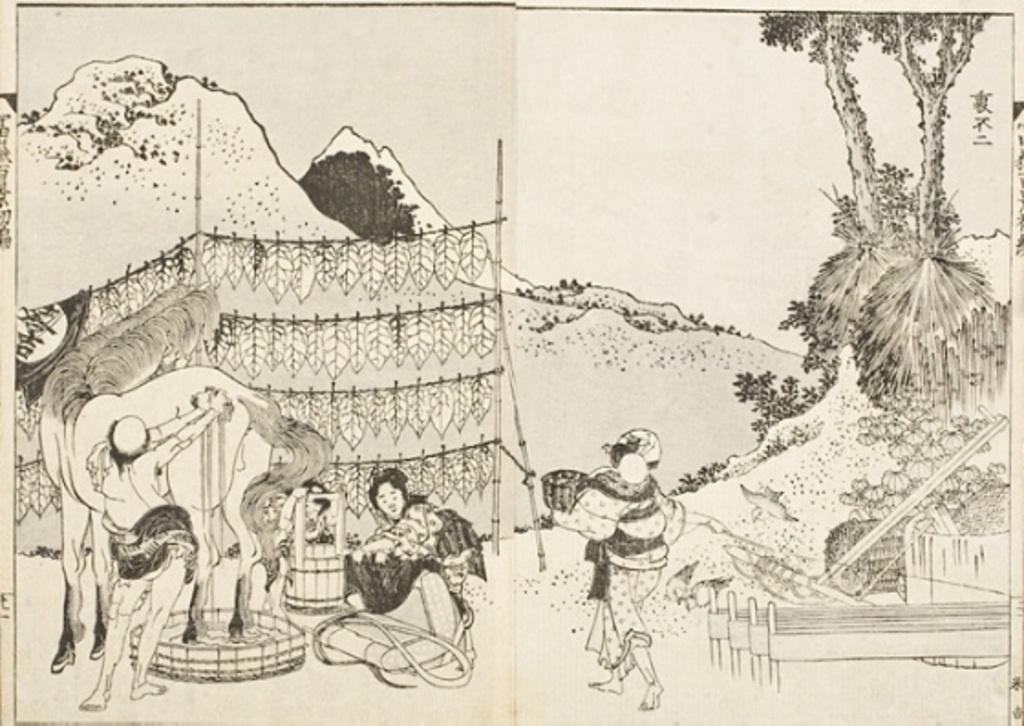What is the main subject in the center of the image? There is a paper in the center of the image. What is depicted on the paper? The paper contains an image or drawing of three persons, a horse, a basket, a cot, hills, trees, and garlands. Can you describe the setting of the image or drawing on the paper? The setting includes hills, trees, and garlands. What type of building can be seen in the image? There is no building present in the image; it features a paper with an image or drawing on it. How many garlands are hanging on the wall in the image? There is no wall present in the image, and therefore no garlands hanging on it. 